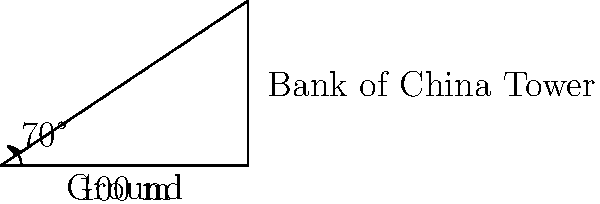You're standing 100 meters away from the base of the Bank of China Tower in Hong Kong. Using a clinometer, you measure the angle to the top of the building to be 70°. Calculate the approximate height of the Bank of China Tower. To solve this problem, we'll use trigonometry, specifically the tangent function. Here's a step-by-step explanation:

1) In a right triangle, tangent of an angle is the ratio of the opposite side to the adjacent side.

2) In this case:
   - The angle is 70°
   - The adjacent side is the distance from you to the base of the tower (100 m)
   - The opposite side is the height of the tower we want to calculate

3) Let's call the height of the tower $h$. We can set up the equation:

   $\tan(70°) = \frac{h}{100}$

4) To find $h$, we multiply both sides by 100:

   $h = 100 \cdot \tan(70°)$

5) Now we can calculate:
   $\tan(70°) \approx 2.7475$
   
   $h = 100 \cdot 2.7475 = 274.75$ meters

6) Rounding to the nearest meter, the height is approximately 275 meters.

Note: The actual height of the Bank of China Tower is 367.4 meters. The discrepancy could be due to factors such as the observation point not being at ground level, or simplifications in our calculation.
Answer: 275 meters 